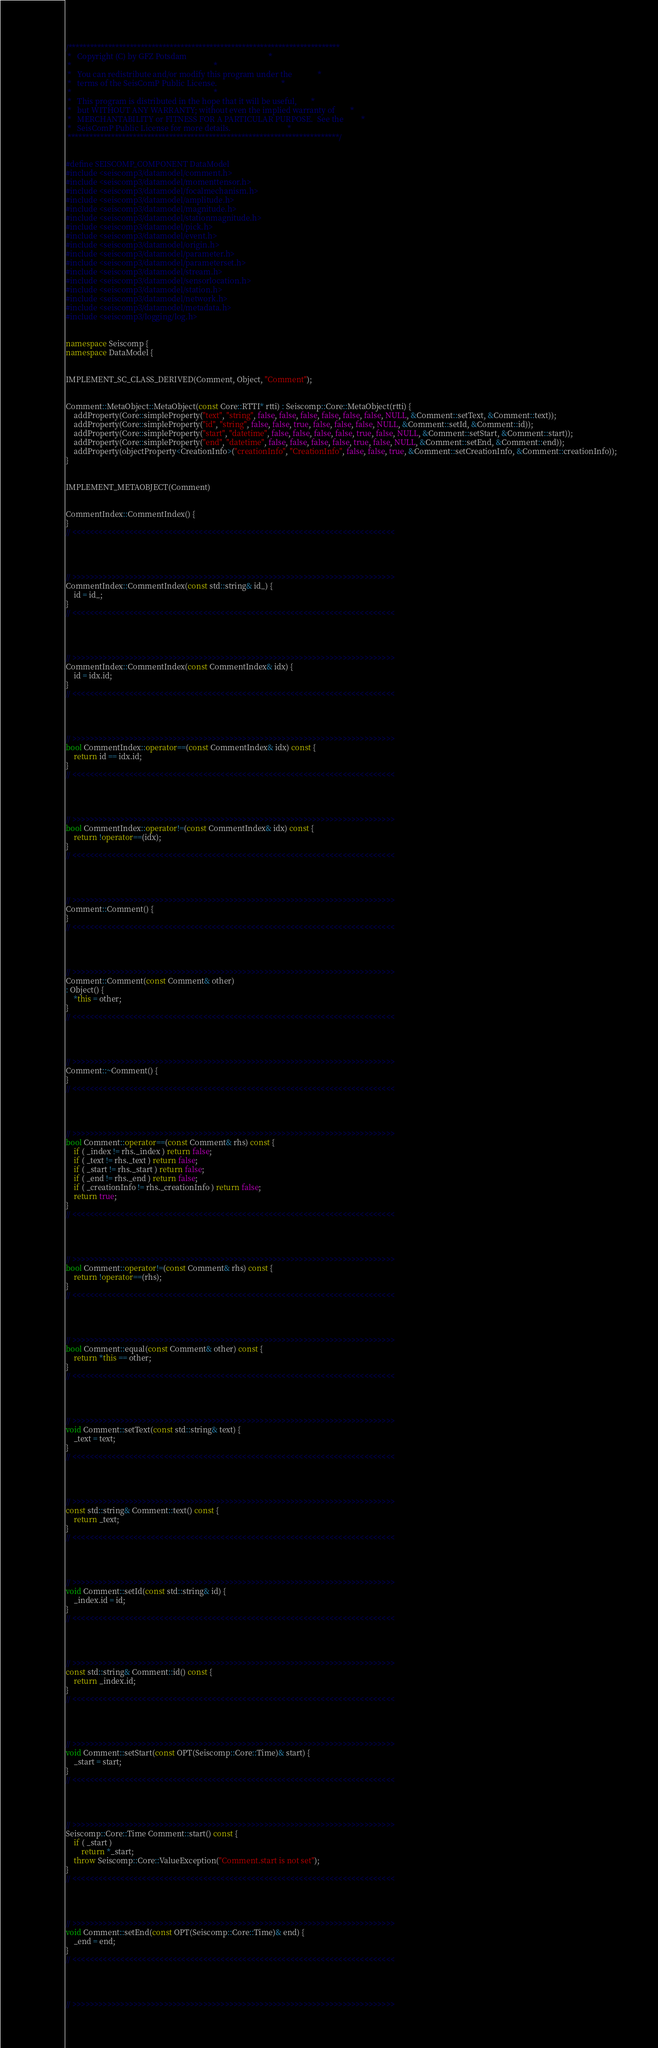<code> <loc_0><loc_0><loc_500><loc_500><_C++_>/***************************************************************************
 *   Copyright (C) by GFZ Potsdam                                          *
 *                                                                         *
 *   You can redistribute and/or modify this program under the             *
 *   terms of the SeisComP Public License.                                 *
 *                                                                         *
 *   This program is distributed in the hope that it will be useful,       *
 *   but WITHOUT ANY WARRANTY; without even the implied warranty of        *
 *   MERCHANTABILITY or FITNESS FOR A PARTICULAR PURPOSE.  See the         *
 *   SeisComP Public License for more details.                             *
 ***************************************************************************/


#define SEISCOMP_COMPONENT DataModel
#include <seiscomp3/datamodel/comment.h>
#include <seiscomp3/datamodel/momenttensor.h>
#include <seiscomp3/datamodel/focalmechanism.h>
#include <seiscomp3/datamodel/amplitude.h>
#include <seiscomp3/datamodel/magnitude.h>
#include <seiscomp3/datamodel/stationmagnitude.h>
#include <seiscomp3/datamodel/pick.h>
#include <seiscomp3/datamodel/event.h>
#include <seiscomp3/datamodel/origin.h>
#include <seiscomp3/datamodel/parameter.h>
#include <seiscomp3/datamodel/parameterset.h>
#include <seiscomp3/datamodel/stream.h>
#include <seiscomp3/datamodel/sensorlocation.h>
#include <seiscomp3/datamodel/station.h>
#include <seiscomp3/datamodel/network.h>
#include <seiscomp3/datamodel/metadata.h>
#include <seiscomp3/logging/log.h>


namespace Seiscomp {
namespace DataModel {


IMPLEMENT_SC_CLASS_DERIVED(Comment, Object, "Comment");


Comment::MetaObject::MetaObject(const Core::RTTI* rtti) : Seiscomp::Core::MetaObject(rtti) {
	addProperty(Core::simpleProperty("text", "string", false, false, false, false, false, false, NULL, &Comment::setText, &Comment::text));
	addProperty(Core::simpleProperty("id", "string", false, false, true, false, false, false, NULL, &Comment::setId, &Comment::id));
	addProperty(Core::simpleProperty("start", "datetime", false, false, false, false, true, false, NULL, &Comment::setStart, &Comment::start));
	addProperty(Core::simpleProperty("end", "datetime", false, false, false, false, true, false, NULL, &Comment::setEnd, &Comment::end));
	addProperty(objectProperty<CreationInfo>("creationInfo", "CreationInfo", false, false, true, &Comment::setCreationInfo, &Comment::creationInfo));
}


IMPLEMENT_METAOBJECT(Comment)


CommentIndex::CommentIndex() {
}
// <<<<<<<<<<<<<<<<<<<<<<<<<<<<<<<<<<<<<<<<<<<<<<<<<<<<<<<<<<<<<<<<<<<<<<<<<<




// >>>>>>>>>>>>>>>>>>>>>>>>>>>>>>>>>>>>>>>>>>>>>>>>>>>>>>>>>>>>>>>>>>>>>>>>>>
CommentIndex::CommentIndex(const std::string& id_) {
	id = id_;
}
// <<<<<<<<<<<<<<<<<<<<<<<<<<<<<<<<<<<<<<<<<<<<<<<<<<<<<<<<<<<<<<<<<<<<<<<<<<




// >>>>>>>>>>>>>>>>>>>>>>>>>>>>>>>>>>>>>>>>>>>>>>>>>>>>>>>>>>>>>>>>>>>>>>>>>>
CommentIndex::CommentIndex(const CommentIndex& idx) {
	id = idx.id;
}
// <<<<<<<<<<<<<<<<<<<<<<<<<<<<<<<<<<<<<<<<<<<<<<<<<<<<<<<<<<<<<<<<<<<<<<<<<<




// >>>>>>>>>>>>>>>>>>>>>>>>>>>>>>>>>>>>>>>>>>>>>>>>>>>>>>>>>>>>>>>>>>>>>>>>>>
bool CommentIndex::operator==(const CommentIndex& idx) const {
	return id == idx.id;
}
// <<<<<<<<<<<<<<<<<<<<<<<<<<<<<<<<<<<<<<<<<<<<<<<<<<<<<<<<<<<<<<<<<<<<<<<<<<




// >>>>>>>>>>>>>>>>>>>>>>>>>>>>>>>>>>>>>>>>>>>>>>>>>>>>>>>>>>>>>>>>>>>>>>>>>>
bool CommentIndex::operator!=(const CommentIndex& idx) const {
	return !operator==(idx);
}
// <<<<<<<<<<<<<<<<<<<<<<<<<<<<<<<<<<<<<<<<<<<<<<<<<<<<<<<<<<<<<<<<<<<<<<<<<<




// >>>>>>>>>>>>>>>>>>>>>>>>>>>>>>>>>>>>>>>>>>>>>>>>>>>>>>>>>>>>>>>>>>>>>>>>>>
Comment::Comment() {
}
// <<<<<<<<<<<<<<<<<<<<<<<<<<<<<<<<<<<<<<<<<<<<<<<<<<<<<<<<<<<<<<<<<<<<<<<<<<




// >>>>>>>>>>>>>>>>>>>>>>>>>>>>>>>>>>>>>>>>>>>>>>>>>>>>>>>>>>>>>>>>>>>>>>>>>>
Comment::Comment(const Comment& other)
: Object() {
	*this = other;
}
// <<<<<<<<<<<<<<<<<<<<<<<<<<<<<<<<<<<<<<<<<<<<<<<<<<<<<<<<<<<<<<<<<<<<<<<<<<




// >>>>>>>>>>>>>>>>>>>>>>>>>>>>>>>>>>>>>>>>>>>>>>>>>>>>>>>>>>>>>>>>>>>>>>>>>>
Comment::~Comment() {
}
// <<<<<<<<<<<<<<<<<<<<<<<<<<<<<<<<<<<<<<<<<<<<<<<<<<<<<<<<<<<<<<<<<<<<<<<<<<




// >>>>>>>>>>>>>>>>>>>>>>>>>>>>>>>>>>>>>>>>>>>>>>>>>>>>>>>>>>>>>>>>>>>>>>>>>>
bool Comment::operator==(const Comment& rhs) const {
	if ( _index != rhs._index ) return false;
	if ( _text != rhs._text ) return false;
	if ( _start != rhs._start ) return false;
	if ( _end != rhs._end ) return false;
	if ( _creationInfo != rhs._creationInfo ) return false;
	return true;
}
// <<<<<<<<<<<<<<<<<<<<<<<<<<<<<<<<<<<<<<<<<<<<<<<<<<<<<<<<<<<<<<<<<<<<<<<<<<




// >>>>>>>>>>>>>>>>>>>>>>>>>>>>>>>>>>>>>>>>>>>>>>>>>>>>>>>>>>>>>>>>>>>>>>>>>>
bool Comment::operator!=(const Comment& rhs) const {
	return !operator==(rhs);
}
// <<<<<<<<<<<<<<<<<<<<<<<<<<<<<<<<<<<<<<<<<<<<<<<<<<<<<<<<<<<<<<<<<<<<<<<<<<




// >>>>>>>>>>>>>>>>>>>>>>>>>>>>>>>>>>>>>>>>>>>>>>>>>>>>>>>>>>>>>>>>>>>>>>>>>>
bool Comment::equal(const Comment& other) const {
	return *this == other;
}
// <<<<<<<<<<<<<<<<<<<<<<<<<<<<<<<<<<<<<<<<<<<<<<<<<<<<<<<<<<<<<<<<<<<<<<<<<<




// >>>>>>>>>>>>>>>>>>>>>>>>>>>>>>>>>>>>>>>>>>>>>>>>>>>>>>>>>>>>>>>>>>>>>>>>>>
void Comment::setText(const std::string& text) {
	_text = text;
}
// <<<<<<<<<<<<<<<<<<<<<<<<<<<<<<<<<<<<<<<<<<<<<<<<<<<<<<<<<<<<<<<<<<<<<<<<<<




// >>>>>>>>>>>>>>>>>>>>>>>>>>>>>>>>>>>>>>>>>>>>>>>>>>>>>>>>>>>>>>>>>>>>>>>>>>
const std::string& Comment::text() const {
	return _text;
}
// <<<<<<<<<<<<<<<<<<<<<<<<<<<<<<<<<<<<<<<<<<<<<<<<<<<<<<<<<<<<<<<<<<<<<<<<<<




// >>>>>>>>>>>>>>>>>>>>>>>>>>>>>>>>>>>>>>>>>>>>>>>>>>>>>>>>>>>>>>>>>>>>>>>>>>
void Comment::setId(const std::string& id) {
	_index.id = id;
}
// <<<<<<<<<<<<<<<<<<<<<<<<<<<<<<<<<<<<<<<<<<<<<<<<<<<<<<<<<<<<<<<<<<<<<<<<<<




// >>>>>>>>>>>>>>>>>>>>>>>>>>>>>>>>>>>>>>>>>>>>>>>>>>>>>>>>>>>>>>>>>>>>>>>>>>
const std::string& Comment::id() const {
	return _index.id;
}
// <<<<<<<<<<<<<<<<<<<<<<<<<<<<<<<<<<<<<<<<<<<<<<<<<<<<<<<<<<<<<<<<<<<<<<<<<<




// >>>>>>>>>>>>>>>>>>>>>>>>>>>>>>>>>>>>>>>>>>>>>>>>>>>>>>>>>>>>>>>>>>>>>>>>>>
void Comment::setStart(const OPT(Seiscomp::Core::Time)& start) {
	_start = start;
}
// <<<<<<<<<<<<<<<<<<<<<<<<<<<<<<<<<<<<<<<<<<<<<<<<<<<<<<<<<<<<<<<<<<<<<<<<<<




// >>>>>>>>>>>>>>>>>>>>>>>>>>>>>>>>>>>>>>>>>>>>>>>>>>>>>>>>>>>>>>>>>>>>>>>>>>
Seiscomp::Core::Time Comment::start() const {
	if ( _start )
		return *_start;
	throw Seiscomp::Core::ValueException("Comment.start is not set");
}
// <<<<<<<<<<<<<<<<<<<<<<<<<<<<<<<<<<<<<<<<<<<<<<<<<<<<<<<<<<<<<<<<<<<<<<<<<<




// >>>>>>>>>>>>>>>>>>>>>>>>>>>>>>>>>>>>>>>>>>>>>>>>>>>>>>>>>>>>>>>>>>>>>>>>>>
void Comment::setEnd(const OPT(Seiscomp::Core::Time)& end) {
	_end = end;
}
// <<<<<<<<<<<<<<<<<<<<<<<<<<<<<<<<<<<<<<<<<<<<<<<<<<<<<<<<<<<<<<<<<<<<<<<<<<




// >>>>>>>>>>>>>>>>>>>>>>>>>>>>>>>>>>>>>>>>>>>>>>>>>>>>>>>>>>>>>>>>>>>>>>>>>></code> 